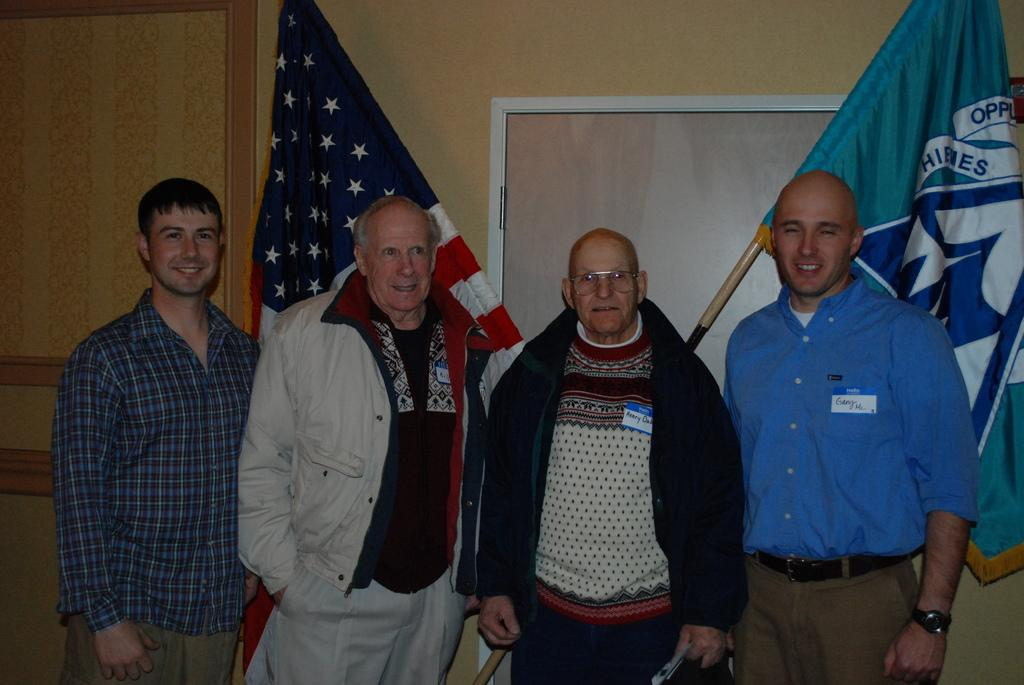How many people are in the image? There are four persons in the image. What expressions do the persons have? The persons are standing with smiles on their faces. What can be seen behind the persons? There are flags visible behind the persons. What type of wall is in the background? There is a wooden wall with a door in the background. Can you tell me how many goats are standing next to the persons in the image? There are no goats present in the image; only the four persons and the flags are visible. What type of polish is being applied to the wooden wall in the image? There is no indication in the image that any polish is being applied to the wooden wall; it is simply a part of the background. 